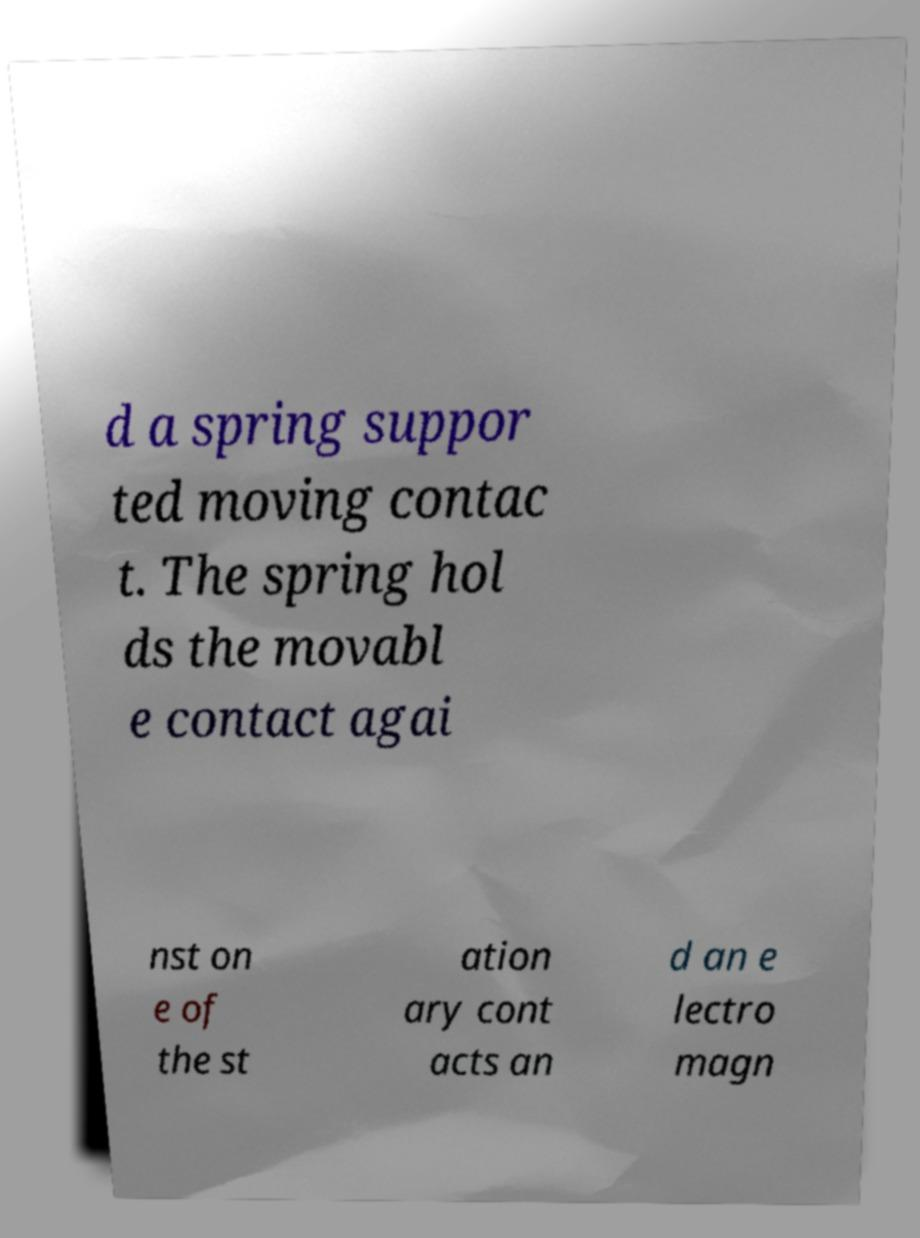Can you accurately transcribe the text from the provided image for me? d a spring suppor ted moving contac t. The spring hol ds the movabl e contact agai nst on e of the st ation ary cont acts an d an e lectro magn 